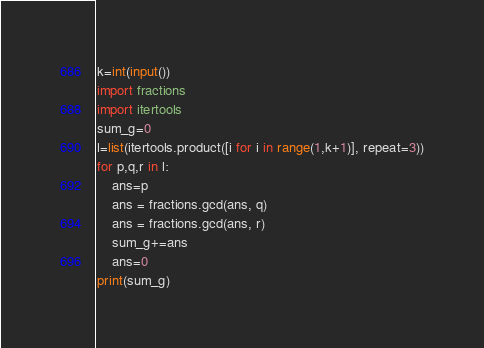Convert code to text. <code><loc_0><loc_0><loc_500><loc_500><_Python_>k=int(input())
import fractions
import itertools
sum_g=0
l=list(itertools.product([i for i in range(1,k+1)], repeat=3))
for p,q,r in l:
    ans=p
    ans = fractions.gcd(ans, q)
    ans = fractions.gcd(ans, r)
    sum_g+=ans
    ans=0
print(sum_g)
</code> 